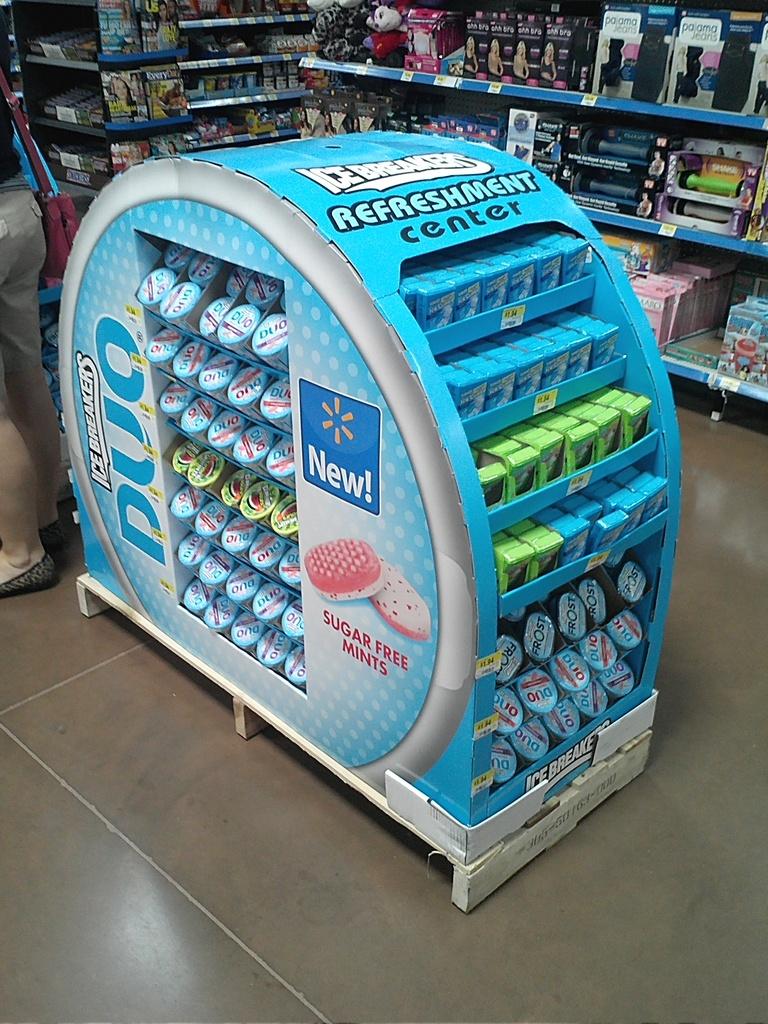What kind of mints are those?
Your response must be concise. Ice breakers. 